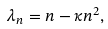Convert formula to latex. <formula><loc_0><loc_0><loc_500><loc_500>\lambda _ { n } = n - \kappa n ^ { 2 } ,</formula> 